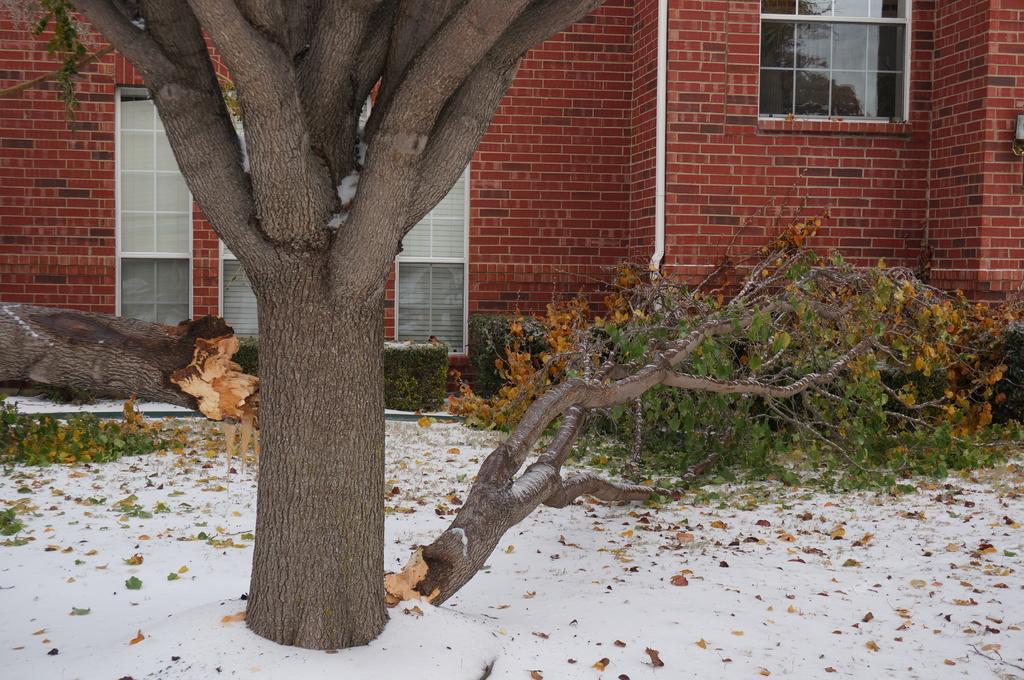Can you describe this image briefly? In this picture we can see a tree here, at the bottom there are some leaves and snow, we can see a trunk of the tree here, in the background there is a building, we can see a glass window here. 